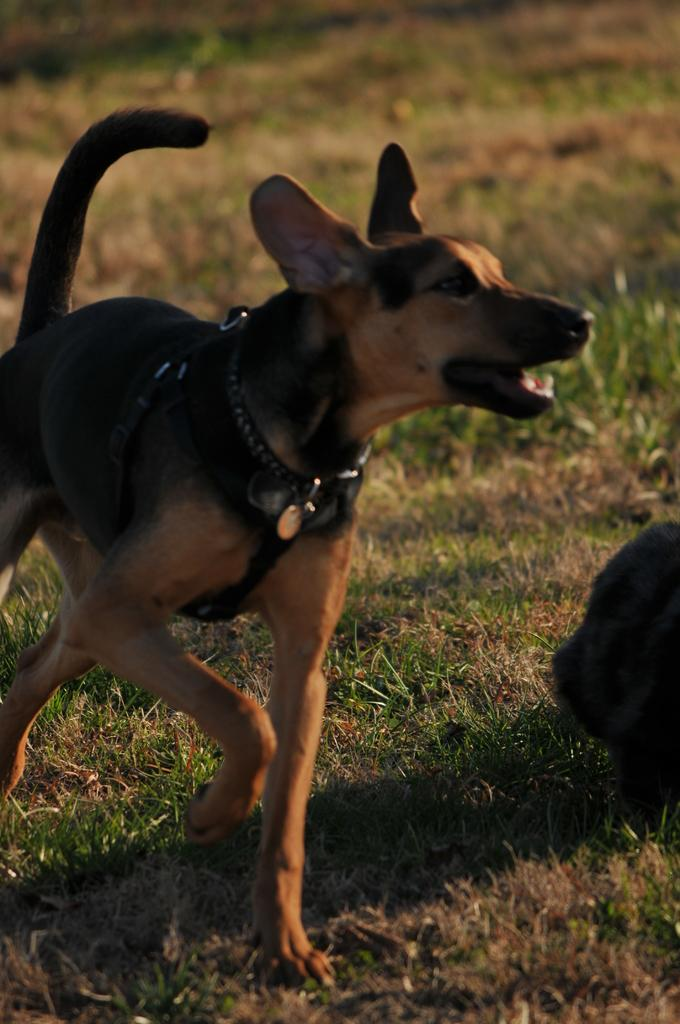What animal is present in the image? There is a dog in the picture. What is the color of the dog? The dog is brown in color. Is there anything around the dog's neck? Yes, there is a belt around the dog's neck. What type of terrain is visible at the bottom of the picture? There is grass at the bottom of the picture. What year is depicted in the image? There is no specific year depicted in the image; it is a picture of a dog with a belt around its neck and grass at the bottom. 